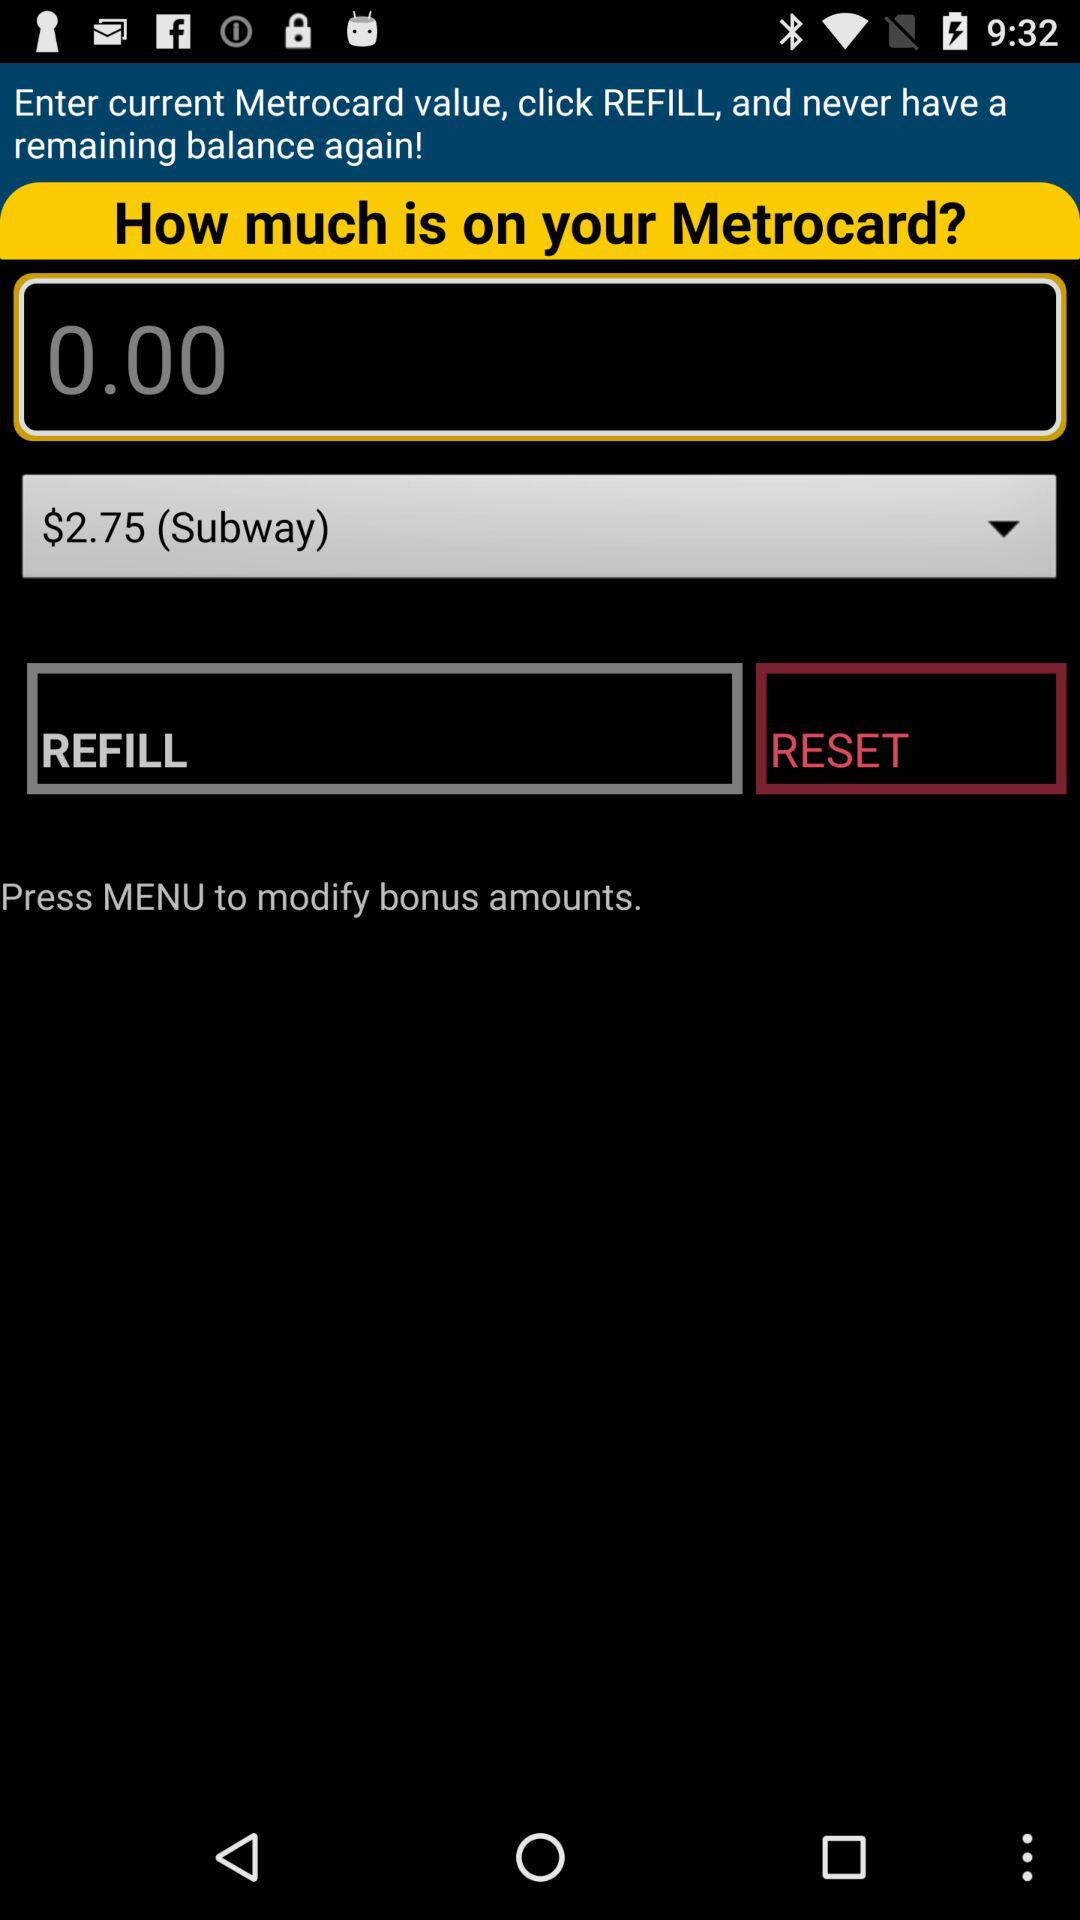How much balance is left on MasterCard?
When the provided information is insufficient, respond with <no answer>. <no answer> 